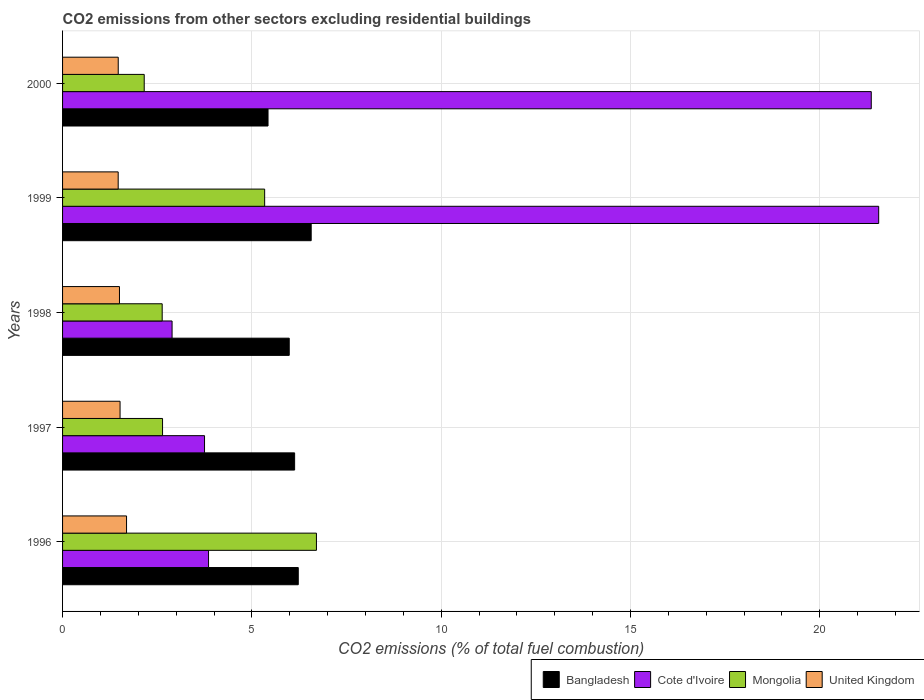How many different coloured bars are there?
Offer a very short reply. 4. Are the number of bars on each tick of the Y-axis equal?
Give a very brief answer. Yes. In how many cases, is the number of bars for a given year not equal to the number of legend labels?
Offer a very short reply. 0. What is the total CO2 emitted in Bangladesh in 1999?
Keep it short and to the point. 6.57. Across all years, what is the maximum total CO2 emitted in Mongolia?
Ensure brevity in your answer.  6.71. Across all years, what is the minimum total CO2 emitted in Cote d'Ivoire?
Offer a very short reply. 2.89. In which year was the total CO2 emitted in Mongolia minimum?
Offer a terse response. 2000. What is the total total CO2 emitted in Cote d'Ivoire in the graph?
Your response must be concise. 53.42. What is the difference between the total CO2 emitted in Bangladesh in 1996 and that in 1997?
Give a very brief answer. 0.1. What is the difference between the total CO2 emitted in United Kingdom in 1996 and the total CO2 emitted in Cote d'Ivoire in 1999?
Your answer should be compact. -19.87. What is the average total CO2 emitted in Cote d'Ivoire per year?
Make the answer very short. 10.68. In the year 1996, what is the difference between the total CO2 emitted in Bangladesh and total CO2 emitted in Cote d'Ivoire?
Your answer should be very brief. 2.37. What is the ratio of the total CO2 emitted in Bangladesh in 1996 to that in 1997?
Make the answer very short. 1.02. Is the total CO2 emitted in Mongolia in 1999 less than that in 2000?
Provide a succinct answer. No. Is the difference between the total CO2 emitted in Bangladesh in 1996 and 1998 greater than the difference between the total CO2 emitted in Cote d'Ivoire in 1996 and 1998?
Offer a very short reply. No. What is the difference between the highest and the second highest total CO2 emitted in United Kingdom?
Ensure brevity in your answer.  0.17. What is the difference between the highest and the lowest total CO2 emitted in Mongolia?
Your response must be concise. 4.55. In how many years, is the total CO2 emitted in Bangladesh greater than the average total CO2 emitted in Bangladesh taken over all years?
Provide a succinct answer. 3. Is the sum of the total CO2 emitted in Cote d'Ivoire in 1999 and 2000 greater than the maximum total CO2 emitted in Mongolia across all years?
Offer a terse response. Yes. What does the 2nd bar from the bottom in 1997 represents?
Your response must be concise. Cote d'Ivoire. What is the difference between two consecutive major ticks on the X-axis?
Provide a succinct answer. 5. Are the values on the major ticks of X-axis written in scientific E-notation?
Your answer should be very brief. No. Where does the legend appear in the graph?
Your answer should be very brief. Bottom right. How many legend labels are there?
Offer a terse response. 4. How are the legend labels stacked?
Provide a succinct answer. Horizontal. What is the title of the graph?
Make the answer very short. CO2 emissions from other sectors excluding residential buildings. What is the label or title of the X-axis?
Give a very brief answer. CO2 emissions (% of total fuel combustion). What is the label or title of the Y-axis?
Offer a terse response. Years. What is the CO2 emissions (% of total fuel combustion) of Bangladesh in 1996?
Provide a succinct answer. 6.23. What is the CO2 emissions (% of total fuel combustion) of Cote d'Ivoire in 1996?
Make the answer very short. 3.86. What is the CO2 emissions (% of total fuel combustion) of Mongolia in 1996?
Your response must be concise. 6.71. What is the CO2 emissions (% of total fuel combustion) in United Kingdom in 1996?
Offer a terse response. 1.69. What is the CO2 emissions (% of total fuel combustion) of Bangladesh in 1997?
Offer a very short reply. 6.13. What is the CO2 emissions (% of total fuel combustion) in Cote d'Ivoire in 1997?
Your response must be concise. 3.75. What is the CO2 emissions (% of total fuel combustion) of Mongolia in 1997?
Give a very brief answer. 2.64. What is the CO2 emissions (% of total fuel combustion) in United Kingdom in 1997?
Ensure brevity in your answer.  1.52. What is the CO2 emissions (% of total fuel combustion) in Bangladesh in 1998?
Give a very brief answer. 5.99. What is the CO2 emissions (% of total fuel combustion) in Cote d'Ivoire in 1998?
Make the answer very short. 2.89. What is the CO2 emissions (% of total fuel combustion) of Mongolia in 1998?
Keep it short and to the point. 2.63. What is the CO2 emissions (% of total fuel combustion) of United Kingdom in 1998?
Provide a short and direct response. 1.5. What is the CO2 emissions (% of total fuel combustion) in Bangladesh in 1999?
Offer a terse response. 6.57. What is the CO2 emissions (% of total fuel combustion) in Cote d'Ivoire in 1999?
Give a very brief answer. 21.56. What is the CO2 emissions (% of total fuel combustion) in Mongolia in 1999?
Provide a short and direct response. 5.34. What is the CO2 emissions (% of total fuel combustion) of United Kingdom in 1999?
Make the answer very short. 1.47. What is the CO2 emissions (% of total fuel combustion) in Bangladesh in 2000?
Offer a terse response. 5.43. What is the CO2 emissions (% of total fuel combustion) of Cote d'Ivoire in 2000?
Provide a short and direct response. 21.36. What is the CO2 emissions (% of total fuel combustion) in Mongolia in 2000?
Give a very brief answer. 2.16. What is the CO2 emissions (% of total fuel combustion) of United Kingdom in 2000?
Give a very brief answer. 1.47. Across all years, what is the maximum CO2 emissions (% of total fuel combustion) of Bangladesh?
Provide a succinct answer. 6.57. Across all years, what is the maximum CO2 emissions (% of total fuel combustion) in Cote d'Ivoire?
Offer a terse response. 21.56. Across all years, what is the maximum CO2 emissions (% of total fuel combustion) of Mongolia?
Provide a succinct answer. 6.71. Across all years, what is the maximum CO2 emissions (% of total fuel combustion) of United Kingdom?
Your answer should be very brief. 1.69. Across all years, what is the minimum CO2 emissions (% of total fuel combustion) in Bangladesh?
Your answer should be very brief. 5.43. Across all years, what is the minimum CO2 emissions (% of total fuel combustion) of Cote d'Ivoire?
Keep it short and to the point. 2.89. Across all years, what is the minimum CO2 emissions (% of total fuel combustion) in Mongolia?
Provide a succinct answer. 2.16. Across all years, what is the minimum CO2 emissions (% of total fuel combustion) of United Kingdom?
Keep it short and to the point. 1.47. What is the total CO2 emissions (% of total fuel combustion) of Bangladesh in the graph?
Give a very brief answer. 30.34. What is the total CO2 emissions (% of total fuel combustion) in Cote d'Ivoire in the graph?
Your answer should be compact. 53.42. What is the total CO2 emissions (% of total fuel combustion) in Mongolia in the graph?
Give a very brief answer. 19.47. What is the total CO2 emissions (% of total fuel combustion) in United Kingdom in the graph?
Ensure brevity in your answer.  7.65. What is the difference between the CO2 emissions (% of total fuel combustion) of Bangladesh in 1996 and that in 1997?
Keep it short and to the point. 0.1. What is the difference between the CO2 emissions (% of total fuel combustion) in Cote d'Ivoire in 1996 and that in 1997?
Provide a short and direct response. 0.11. What is the difference between the CO2 emissions (% of total fuel combustion) of Mongolia in 1996 and that in 1997?
Your answer should be compact. 4.06. What is the difference between the CO2 emissions (% of total fuel combustion) in United Kingdom in 1996 and that in 1997?
Offer a very short reply. 0.17. What is the difference between the CO2 emissions (% of total fuel combustion) in Bangladesh in 1996 and that in 1998?
Keep it short and to the point. 0.24. What is the difference between the CO2 emissions (% of total fuel combustion) of Cote d'Ivoire in 1996 and that in 1998?
Keep it short and to the point. 0.96. What is the difference between the CO2 emissions (% of total fuel combustion) in Mongolia in 1996 and that in 1998?
Make the answer very short. 4.07. What is the difference between the CO2 emissions (% of total fuel combustion) in United Kingdom in 1996 and that in 1998?
Make the answer very short. 0.19. What is the difference between the CO2 emissions (% of total fuel combustion) of Bangladesh in 1996 and that in 1999?
Make the answer very short. -0.34. What is the difference between the CO2 emissions (% of total fuel combustion) in Cote d'Ivoire in 1996 and that in 1999?
Your response must be concise. -17.7. What is the difference between the CO2 emissions (% of total fuel combustion) in Mongolia in 1996 and that in 1999?
Provide a short and direct response. 1.37. What is the difference between the CO2 emissions (% of total fuel combustion) of United Kingdom in 1996 and that in 1999?
Offer a very short reply. 0.22. What is the difference between the CO2 emissions (% of total fuel combustion) in Bangladesh in 1996 and that in 2000?
Provide a short and direct response. 0.8. What is the difference between the CO2 emissions (% of total fuel combustion) of Cote d'Ivoire in 1996 and that in 2000?
Your answer should be compact. -17.5. What is the difference between the CO2 emissions (% of total fuel combustion) of Mongolia in 1996 and that in 2000?
Ensure brevity in your answer.  4.55. What is the difference between the CO2 emissions (% of total fuel combustion) in United Kingdom in 1996 and that in 2000?
Offer a terse response. 0.22. What is the difference between the CO2 emissions (% of total fuel combustion) of Bangladesh in 1997 and that in 1998?
Your answer should be compact. 0.14. What is the difference between the CO2 emissions (% of total fuel combustion) of Cote d'Ivoire in 1997 and that in 1998?
Offer a very short reply. 0.86. What is the difference between the CO2 emissions (% of total fuel combustion) of Mongolia in 1997 and that in 1998?
Your answer should be compact. 0.01. What is the difference between the CO2 emissions (% of total fuel combustion) in United Kingdom in 1997 and that in 1998?
Offer a terse response. 0.02. What is the difference between the CO2 emissions (% of total fuel combustion) in Bangladesh in 1997 and that in 1999?
Provide a succinct answer. -0.44. What is the difference between the CO2 emissions (% of total fuel combustion) in Cote d'Ivoire in 1997 and that in 1999?
Ensure brevity in your answer.  -17.81. What is the difference between the CO2 emissions (% of total fuel combustion) in Mongolia in 1997 and that in 1999?
Your answer should be very brief. -2.7. What is the difference between the CO2 emissions (% of total fuel combustion) of United Kingdom in 1997 and that in 1999?
Provide a succinct answer. 0.05. What is the difference between the CO2 emissions (% of total fuel combustion) in Bangladesh in 1997 and that in 2000?
Offer a very short reply. 0.7. What is the difference between the CO2 emissions (% of total fuel combustion) of Cote d'Ivoire in 1997 and that in 2000?
Your answer should be compact. -17.61. What is the difference between the CO2 emissions (% of total fuel combustion) in Mongolia in 1997 and that in 2000?
Provide a short and direct response. 0.48. What is the difference between the CO2 emissions (% of total fuel combustion) in United Kingdom in 1997 and that in 2000?
Your answer should be compact. 0.05. What is the difference between the CO2 emissions (% of total fuel combustion) in Bangladesh in 1998 and that in 1999?
Provide a succinct answer. -0.58. What is the difference between the CO2 emissions (% of total fuel combustion) of Cote d'Ivoire in 1998 and that in 1999?
Your answer should be very brief. -18.66. What is the difference between the CO2 emissions (% of total fuel combustion) of Mongolia in 1998 and that in 1999?
Offer a terse response. -2.71. What is the difference between the CO2 emissions (% of total fuel combustion) in United Kingdom in 1998 and that in 1999?
Keep it short and to the point. 0.03. What is the difference between the CO2 emissions (% of total fuel combustion) in Bangladesh in 1998 and that in 2000?
Offer a very short reply. 0.56. What is the difference between the CO2 emissions (% of total fuel combustion) in Cote d'Ivoire in 1998 and that in 2000?
Your answer should be compact. -18.47. What is the difference between the CO2 emissions (% of total fuel combustion) in Mongolia in 1998 and that in 2000?
Make the answer very short. 0.47. What is the difference between the CO2 emissions (% of total fuel combustion) of United Kingdom in 1998 and that in 2000?
Make the answer very short. 0.03. What is the difference between the CO2 emissions (% of total fuel combustion) in Bangladesh in 1999 and that in 2000?
Ensure brevity in your answer.  1.14. What is the difference between the CO2 emissions (% of total fuel combustion) in Cote d'Ivoire in 1999 and that in 2000?
Provide a short and direct response. 0.2. What is the difference between the CO2 emissions (% of total fuel combustion) in Mongolia in 1999 and that in 2000?
Your answer should be compact. 3.18. What is the difference between the CO2 emissions (% of total fuel combustion) of United Kingdom in 1999 and that in 2000?
Give a very brief answer. -0. What is the difference between the CO2 emissions (% of total fuel combustion) in Bangladesh in 1996 and the CO2 emissions (% of total fuel combustion) in Cote d'Ivoire in 1997?
Keep it short and to the point. 2.48. What is the difference between the CO2 emissions (% of total fuel combustion) in Bangladesh in 1996 and the CO2 emissions (% of total fuel combustion) in Mongolia in 1997?
Your response must be concise. 3.58. What is the difference between the CO2 emissions (% of total fuel combustion) of Bangladesh in 1996 and the CO2 emissions (% of total fuel combustion) of United Kingdom in 1997?
Offer a very short reply. 4.71. What is the difference between the CO2 emissions (% of total fuel combustion) of Cote d'Ivoire in 1996 and the CO2 emissions (% of total fuel combustion) of Mongolia in 1997?
Provide a short and direct response. 1.22. What is the difference between the CO2 emissions (% of total fuel combustion) in Cote d'Ivoire in 1996 and the CO2 emissions (% of total fuel combustion) in United Kingdom in 1997?
Your answer should be compact. 2.34. What is the difference between the CO2 emissions (% of total fuel combustion) of Mongolia in 1996 and the CO2 emissions (% of total fuel combustion) of United Kingdom in 1997?
Provide a succinct answer. 5.19. What is the difference between the CO2 emissions (% of total fuel combustion) in Bangladesh in 1996 and the CO2 emissions (% of total fuel combustion) in Cote d'Ivoire in 1998?
Make the answer very short. 3.33. What is the difference between the CO2 emissions (% of total fuel combustion) of Bangladesh in 1996 and the CO2 emissions (% of total fuel combustion) of Mongolia in 1998?
Your answer should be compact. 3.59. What is the difference between the CO2 emissions (% of total fuel combustion) in Bangladesh in 1996 and the CO2 emissions (% of total fuel combustion) in United Kingdom in 1998?
Your answer should be very brief. 4.72. What is the difference between the CO2 emissions (% of total fuel combustion) of Cote d'Ivoire in 1996 and the CO2 emissions (% of total fuel combustion) of Mongolia in 1998?
Offer a terse response. 1.22. What is the difference between the CO2 emissions (% of total fuel combustion) in Cote d'Ivoire in 1996 and the CO2 emissions (% of total fuel combustion) in United Kingdom in 1998?
Keep it short and to the point. 2.35. What is the difference between the CO2 emissions (% of total fuel combustion) of Mongolia in 1996 and the CO2 emissions (% of total fuel combustion) of United Kingdom in 1998?
Your answer should be very brief. 5.2. What is the difference between the CO2 emissions (% of total fuel combustion) in Bangladesh in 1996 and the CO2 emissions (% of total fuel combustion) in Cote d'Ivoire in 1999?
Offer a terse response. -15.33. What is the difference between the CO2 emissions (% of total fuel combustion) in Bangladesh in 1996 and the CO2 emissions (% of total fuel combustion) in Mongolia in 1999?
Give a very brief answer. 0.89. What is the difference between the CO2 emissions (% of total fuel combustion) of Bangladesh in 1996 and the CO2 emissions (% of total fuel combustion) of United Kingdom in 1999?
Make the answer very short. 4.76. What is the difference between the CO2 emissions (% of total fuel combustion) of Cote d'Ivoire in 1996 and the CO2 emissions (% of total fuel combustion) of Mongolia in 1999?
Your answer should be very brief. -1.48. What is the difference between the CO2 emissions (% of total fuel combustion) in Cote d'Ivoire in 1996 and the CO2 emissions (% of total fuel combustion) in United Kingdom in 1999?
Keep it short and to the point. 2.39. What is the difference between the CO2 emissions (% of total fuel combustion) of Mongolia in 1996 and the CO2 emissions (% of total fuel combustion) of United Kingdom in 1999?
Your answer should be compact. 5.24. What is the difference between the CO2 emissions (% of total fuel combustion) in Bangladesh in 1996 and the CO2 emissions (% of total fuel combustion) in Cote d'Ivoire in 2000?
Give a very brief answer. -15.14. What is the difference between the CO2 emissions (% of total fuel combustion) of Bangladesh in 1996 and the CO2 emissions (% of total fuel combustion) of Mongolia in 2000?
Give a very brief answer. 4.07. What is the difference between the CO2 emissions (% of total fuel combustion) of Bangladesh in 1996 and the CO2 emissions (% of total fuel combustion) of United Kingdom in 2000?
Offer a terse response. 4.76. What is the difference between the CO2 emissions (% of total fuel combustion) in Cote d'Ivoire in 1996 and the CO2 emissions (% of total fuel combustion) in Mongolia in 2000?
Make the answer very short. 1.7. What is the difference between the CO2 emissions (% of total fuel combustion) in Cote d'Ivoire in 1996 and the CO2 emissions (% of total fuel combustion) in United Kingdom in 2000?
Offer a very short reply. 2.39. What is the difference between the CO2 emissions (% of total fuel combustion) in Mongolia in 1996 and the CO2 emissions (% of total fuel combustion) in United Kingdom in 2000?
Keep it short and to the point. 5.24. What is the difference between the CO2 emissions (% of total fuel combustion) in Bangladesh in 1997 and the CO2 emissions (% of total fuel combustion) in Cote d'Ivoire in 1998?
Provide a succinct answer. 3.24. What is the difference between the CO2 emissions (% of total fuel combustion) of Bangladesh in 1997 and the CO2 emissions (% of total fuel combustion) of Mongolia in 1998?
Ensure brevity in your answer.  3.5. What is the difference between the CO2 emissions (% of total fuel combustion) in Bangladesh in 1997 and the CO2 emissions (% of total fuel combustion) in United Kingdom in 1998?
Provide a succinct answer. 4.63. What is the difference between the CO2 emissions (% of total fuel combustion) of Cote d'Ivoire in 1997 and the CO2 emissions (% of total fuel combustion) of Mongolia in 1998?
Provide a succinct answer. 1.12. What is the difference between the CO2 emissions (% of total fuel combustion) in Cote d'Ivoire in 1997 and the CO2 emissions (% of total fuel combustion) in United Kingdom in 1998?
Your answer should be very brief. 2.25. What is the difference between the CO2 emissions (% of total fuel combustion) in Mongolia in 1997 and the CO2 emissions (% of total fuel combustion) in United Kingdom in 1998?
Your response must be concise. 1.14. What is the difference between the CO2 emissions (% of total fuel combustion) of Bangladesh in 1997 and the CO2 emissions (% of total fuel combustion) of Cote d'Ivoire in 1999?
Make the answer very short. -15.43. What is the difference between the CO2 emissions (% of total fuel combustion) of Bangladesh in 1997 and the CO2 emissions (% of total fuel combustion) of Mongolia in 1999?
Make the answer very short. 0.79. What is the difference between the CO2 emissions (% of total fuel combustion) of Bangladesh in 1997 and the CO2 emissions (% of total fuel combustion) of United Kingdom in 1999?
Offer a terse response. 4.66. What is the difference between the CO2 emissions (% of total fuel combustion) in Cote d'Ivoire in 1997 and the CO2 emissions (% of total fuel combustion) in Mongolia in 1999?
Your answer should be very brief. -1.59. What is the difference between the CO2 emissions (% of total fuel combustion) of Cote d'Ivoire in 1997 and the CO2 emissions (% of total fuel combustion) of United Kingdom in 1999?
Provide a short and direct response. 2.28. What is the difference between the CO2 emissions (% of total fuel combustion) in Mongolia in 1997 and the CO2 emissions (% of total fuel combustion) in United Kingdom in 1999?
Offer a terse response. 1.17. What is the difference between the CO2 emissions (% of total fuel combustion) of Bangladesh in 1997 and the CO2 emissions (% of total fuel combustion) of Cote d'Ivoire in 2000?
Provide a short and direct response. -15.23. What is the difference between the CO2 emissions (% of total fuel combustion) in Bangladesh in 1997 and the CO2 emissions (% of total fuel combustion) in Mongolia in 2000?
Give a very brief answer. 3.97. What is the difference between the CO2 emissions (% of total fuel combustion) of Bangladesh in 1997 and the CO2 emissions (% of total fuel combustion) of United Kingdom in 2000?
Give a very brief answer. 4.66. What is the difference between the CO2 emissions (% of total fuel combustion) in Cote d'Ivoire in 1997 and the CO2 emissions (% of total fuel combustion) in Mongolia in 2000?
Ensure brevity in your answer.  1.59. What is the difference between the CO2 emissions (% of total fuel combustion) of Cote d'Ivoire in 1997 and the CO2 emissions (% of total fuel combustion) of United Kingdom in 2000?
Keep it short and to the point. 2.28. What is the difference between the CO2 emissions (% of total fuel combustion) in Mongolia in 1997 and the CO2 emissions (% of total fuel combustion) in United Kingdom in 2000?
Keep it short and to the point. 1.17. What is the difference between the CO2 emissions (% of total fuel combustion) of Bangladesh in 1998 and the CO2 emissions (% of total fuel combustion) of Cote d'Ivoire in 1999?
Provide a short and direct response. -15.57. What is the difference between the CO2 emissions (% of total fuel combustion) in Bangladesh in 1998 and the CO2 emissions (% of total fuel combustion) in Mongolia in 1999?
Give a very brief answer. 0.65. What is the difference between the CO2 emissions (% of total fuel combustion) in Bangladesh in 1998 and the CO2 emissions (% of total fuel combustion) in United Kingdom in 1999?
Make the answer very short. 4.52. What is the difference between the CO2 emissions (% of total fuel combustion) of Cote d'Ivoire in 1998 and the CO2 emissions (% of total fuel combustion) of Mongolia in 1999?
Your answer should be compact. -2.45. What is the difference between the CO2 emissions (% of total fuel combustion) of Cote d'Ivoire in 1998 and the CO2 emissions (% of total fuel combustion) of United Kingdom in 1999?
Offer a very short reply. 1.42. What is the difference between the CO2 emissions (% of total fuel combustion) of Mongolia in 1998 and the CO2 emissions (% of total fuel combustion) of United Kingdom in 1999?
Your response must be concise. 1.16. What is the difference between the CO2 emissions (% of total fuel combustion) of Bangladesh in 1998 and the CO2 emissions (% of total fuel combustion) of Cote d'Ivoire in 2000?
Offer a terse response. -15.37. What is the difference between the CO2 emissions (% of total fuel combustion) of Bangladesh in 1998 and the CO2 emissions (% of total fuel combustion) of Mongolia in 2000?
Provide a succinct answer. 3.83. What is the difference between the CO2 emissions (% of total fuel combustion) of Bangladesh in 1998 and the CO2 emissions (% of total fuel combustion) of United Kingdom in 2000?
Make the answer very short. 4.52. What is the difference between the CO2 emissions (% of total fuel combustion) in Cote d'Ivoire in 1998 and the CO2 emissions (% of total fuel combustion) in Mongolia in 2000?
Give a very brief answer. 0.74. What is the difference between the CO2 emissions (% of total fuel combustion) in Cote d'Ivoire in 1998 and the CO2 emissions (% of total fuel combustion) in United Kingdom in 2000?
Offer a very short reply. 1.42. What is the difference between the CO2 emissions (% of total fuel combustion) of Mongolia in 1998 and the CO2 emissions (% of total fuel combustion) of United Kingdom in 2000?
Ensure brevity in your answer.  1.16. What is the difference between the CO2 emissions (% of total fuel combustion) of Bangladesh in 1999 and the CO2 emissions (% of total fuel combustion) of Cote d'Ivoire in 2000?
Give a very brief answer. -14.79. What is the difference between the CO2 emissions (% of total fuel combustion) in Bangladesh in 1999 and the CO2 emissions (% of total fuel combustion) in Mongolia in 2000?
Give a very brief answer. 4.41. What is the difference between the CO2 emissions (% of total fuel combustion) of Bangladesh in 1999 and the CO2 emissions (% of total fuel combustion) of United Kingdom in 2000?
Provide a succinct answer. 5.1. What is the difference between the CO2 emissions (% of total fuel combustion) in Cote d'Ivoire in 1999 and the CO2 emissions (% of total fuel combustion) in Mongolia in 2000?
Your answer should be very brief. 19.4. What is the difference between the CO2 emissions (% of total fuel combustion) of Cote d'Ivoire in 1999 and the CO2 emissions (% of total fuel combustion) of United Kingdom in 2000?
Your answer should be very brief. 20.09. What is the difference between the CO2 emissions (% of total fuel combustion) of Mongolia in 1999 and the CO2 emissions (% of total fuel combustion) of United Kingdom in 2000?
Provide a succinct answer. 3.87. What is the average CO2 emissions (% of total fuel combustion) of Bangladesh per year?
Provide a succinct answer. 6.07. What is the average CO2 emissions (% of total fuel combustion) in Cote d'Ivoire per year?
Offer a terse response. 10.68. What is the average CO2 emissions (% of total fuel combustion) of Mongolia per year?
Make the answer very short. 3.89. What is the average CO2 emissions (% of total fuel combustion) of United Kingdom per year?
Your answer should be very brief. 1.53. In the year 1996, what is the difference between the CO2 emissions (% of total fuel combustion) in Bangladesh and CO2 emissions (% of total fuel combustion) in Cote d'Ivoire?
Offer a terse response. 2.37. In the year 1996, what is the difference between the CO2 emissions (% of total fuel combustion) of Bangladesh and CO2 emissions (% of total fuel combustion) of Mongolia?
Offer a very short reply. -0.48. In the year 1996, what is the difference between the CO2 emissions (% of total fuel combustion) of Bangladesh and CO2 emissions (% of total fuel combustion) of United Kingdom?
Ensure brevity in your answer.  4.54. In the year 1996, what is the difference between the CO2 emissions (% of total fuel combustion) of Cote d'Ivoire and CO2 emissions (% of total fuel combustion) of Mongolia?
Keep it short and to the point. -2.85. In the year 1996, what is the difference between the CO2 emissions (% of total fuel combustion) of Cote d'Ivoire and CO2 emissions (% of total fuel combustion) of United Kingdom?
Ensure brevity in your answer.  2.17. In the year 1996, what is the difference between the CO2 emissions (% of total fuel combustion) in Mongolia and CO2 emissions (% of total fuel combustion) in United Kingdom?
Your response must be concise. 5.02. In the year 1997, what is the difference between the CO2 emissions (% of total fuel combustion) in Bangladesh and CO2 emissions (% of total fuel combustion) in Cote d'Ivoire?
Offer a terse response. 2.38. In the year 1997, what is the difference between the CO2 emissions (% of total fuel combustion) in Bangladesh and CO2 emissions (% of total fuel combustion) in Mongolia?
Your answer should be very brief. 3.49. In the year 1997, what is the difference between the CO2 emissions (% of total fuel combustion) of Bangladesh and CO2 emissions (% of total fuel combustion) of United Kingdom?
Provide a succinct answer. 4.61. In the year 1997, what is the difference between the CO2 emissions (% of total fuel combustion) of Cote d'Ivoire and CO2 emissions (% of total fuel combustion) of Mongolia?
Offer a terse response. 1.11. In the year 1997, what is the difference between the CO2 emissions (% of total fuel combustion) of Cote d'Ivoire and CO2 emissions (% of total fuel combustion) of United Kingdom?
Offer a terse response. 2.23. In the year 1997, what is the difference between the CO2 emissions (% of total fuel combustion) in Mongolia and CO2 emissions (% of total fuel combustion) in United Kingdom?
Provide a succinct answer. 1.12. In the year 1998, what is the difference between the CO2 emissions (% of total fuel combustion) in Bangladesh and CO2 emissions (% of total fuel combustion) in Cote d'Ivoire?
Your answer should be very brief. 3.09. In the year 1998, what is the difference between the CO2 emissions (% of total fuel combustion) of Bangladesh and CO2 emissions (% of total fuel combustion) of Mongolia?
Provide a succinct answer. 3.36. In the year 1998, what is the difference between the CO2 emissions (% of total fuel combustion) in Bangladesh and CO2 emissions (% of total fuel combustion) in United Kingdom?
Make the answer very short. 4.48. In the year 1998, what is the difference between the CO2 emissions (% of total fuel combustion) in Cote d'Ivoire and CO2 emissions (% of total fuel combustion) in Mongolia?
Offer a terse response. 0.26. In the year 1998, what is the difference between the CO2 emissions (% of total fuel combustion) in Cote d'Ivoire and CO2 emissions (% of total fuel combustion) in United Kingdom?
Offer a very short reply. 1.39. In the year 1998, what is the difference between the CO2 emissions (% of total fuel combustion) of Mongolia and CO2 emissions (% of total fuel combustion) of United Kingdom?
Provide a short and direct response. 1.13. In the year 1999, what is the difference between the CO2 emissions (% of total fuel combustion) of Bangladesh and CO2 emissions (% of total fuel combustion) of Cote d'Ivoire?
Your response must be concise. -14.99. In the year 1999, what is the difference between the CO2 emissions (% of total fuel combustion) in Bangladesh and CO2 emissions (% of total fuel combustion) in Mongolia?
Provide a succinct answer. 1.23. In the year 1999, what is the difference between the CO2 emissions (% of total fuel combustion) in Bangladesh and CO2 emissions (% of total fuel combustion) in United Kingdom?
Provide a short and direct response. 5.1. In the year 1999, what is the difference between the CO2 emissions (% of total fuel combustion) in Cote d'Ivoire and CO2 emissions (% of total fuel combustion) in Mongolia?
Offer a terse response. 16.22. In the year 1999, what is the difference between the CO2 emissions (% of total fuel combustion) in Cote d'Ivoire and CO2 emissions (% of total fuel combustion) in United Kingdom?
Your response must be concise. 20.09. In the year 1999, what is the difference between the CO2 emissions (% of total fuel combustion) in Mongolia and CO2 emissions (% of total fuel combustion) in United Kingdom?
Your answer should be very brief. 3.87. In the year 2000, what is the difference between the CO2 emissions (% of total fuel combustion) of Bangladesh and CO2 emissions (% of total fuel combustion) of Cote d'Ivoire?
Your response must be concise. -15.93. In the year 2000, what is the difference between the CO2 emissions (% of total fuel combustion) of Bangladesh and CO2 emissions (% of total fuel combustion) of Mongolia?
Ensure brevity in your answer.  3.27. In the year 2000, what is the difference between the CO2 emissions (% of total fuel combustion) in Bangladesh and CO2 emissions (% of total fuel combustion) in United Kingdom?
Provide a succinct answer. 3.96. In the year 2000, what is the difference between the CO2 emissions (% of total fuel combustion) of Cote d'Ivoire and CO2 emissions (% of total fuel combustion) of Mongolia?
Provide a short and direct response. 19.2. In the year 2000, what is the difference between the CO2 emissions (% of total fuel combustion) in Cote d'Ivoire and CO2 emissions (% of total fuel combustion) in United Kingdom?
Ensure brevity in your answer.  19.89. In the year 2000, what is the difference between the CO2 emissions (% of total fuel combustion) of Mongolia and CO2 emissions (% of total fuel combustion) of United Kingdom?
Ensure brevity in your answer.  0.69. What is the ratio of the CO2 emissions (% of total fuel combustion) in Bangladesh in 1996 to that in 1997?
Ensure brevity in your answer.  1.02. What is the ratio of the CO2 emissions (% of total fuel combustion) of Cote d'Ivoire in 1996 to that in 1997?
Ensure brevity in your answer.  1.03. What is the ratio of the CO2 emissions (% of total fuel combustion) of Mongolia in 1996 to that in 1997?
Keep it short and to the point. 2.54. What is the ratio of the CO2 emissions (% of total fuel combustion) in United Kingdom in 1996 to that in 1997?
Ensure brevity in your answer.  1.11. What is the ratio of the CO2 emissions (% of total fuel combustion) of Bangladesh in 1996 to that in 1998?
Offer a very short reply. 1.04. What is the ratio of the CO2 emissions (% of total fuel combustion) of Cote d'Ivoire in 1996 to that in 1998?
Provide a short and direct response. 1.33. What is the ratio of the CO2 emissions (% of total fuel combustion) in Mongolia in 1996 to that in 1998?
Your response must be concise. 2.55. What is the ratio of the CO2 emissions (% of total fuel combustion) of United Kingdom in 1996 to that in 1998?
Keep it short and to the point. 1.12. What is the ratio of the CO2 emissions (% of total fuel combustion) of Bangladesh in 1996 to that in 1999?
Offer a very short reply. 0.95. What is the ratio of the CO2 emissions (% of total fuel combustion) in Cote d'Ivoire in 1996 to that in 1999?
Offer a terse response. 0.18. What is the ratio of the CO2 emissions (% of total fuel combustion) of Mongolia in 1996 to that in 1999?
Provide a short and direct response. 1.26. What is the ratio of the CO2 emissions (% of total fuel combustion) of United Kingdom in 1996 to that in 1999?
Provide a short and direct response. 1.15. What is the ratio of the CO2 emissions (% of total fuel combustion) of Bangladesh in 1996 to that in 2000?
Keep it short and to the point. 1.15. What is the ratio of the CO2 emissions (% of total fuel combustion) in Cote d'Ivoire in 1996 to that in 2000?
Give a very brief answer. 0.18. What is the ratio of the CO2 emissions (% of total fuel combustion) of Mongolia in 1996 to that in 2000?
Ensure brevity in your answer.  3.11. What is the ratio of the CO2 emissions (% of total fuel combustion) in United Kingdom in 1996 to that in 2000?
Your response must be concise. 1.15. What is the ratio of the CO2 emissions (% of total fuel combustion) in Bangladesh in 1997 to that in 1998?
Ensure brevity in your answer.  1.02. What is the ratio of the CO2 emissions (% of total fuel combustion) in Cote d'Ivoire in 1997 to that in 1998?
Your answer should be compact. 1.3. What is the ratio of the CO2 emissions (% of total fuel combustion) of Mongolia in 1997 to that in 1998?
Your response must be concise. 1. What is the ratio of the CO2 emissions (% of total fuel combustion) of United Kingdom in 1997 to that in 1998?
Provide a short and direct response. 1.01. What is the ratio of the CO2 emissions (% of total fuel combustion) of Bangladesh in 1997 to that in 1999?
Make the answer very short. 0.93. What is the ratio of the CO2 emissions (% of total fuel combustion) of Cote d'Ivoire in 1997 to that in 1999?
Your answer should be compact. 0.17. What is the ratio of the CO2 emissions (% of total fuel combustion) of Mongolia in 1997 to that in 1999?
Provide a short and direct response. 0.49. What is the ratio of the CO2 emissions (% of total fuel combustion) of United Kingdom in 1997 to that in 1999?
Provide a short and direct response. 1.03. What is the ratio of the CO2 emissions (% of total fuel combustion) of Bangladesh in 1997 to that in 2000?
Keep it short and to the point. 1.13. What is the ratio of the CO2 emissions (% of total fuel combustion) in Cote d'Ivoire in 1997 to that in 2000?
Your response must be concise. 0.18. What is the ratio of the CO2 emissions (% of total fuel combustion) of Mongolia in 1997 to that in 2000?
Ensure brevity in your answer.  1.22. What is the ratio of the CO2 emissions (% of total fuel combustion) in United Kingdom in 1997 to that in 2000?
Your response must be concise. 1.03. What is the ratio of the CO2 emissions (% of total fuel combustion) in Bangladesh in 1998 to that in 1999?
Your response must be concise. 0.91. What is the ratio of the CO2 emissions (% of total fuel combustion) in Cote d'Ivoire in 1998 to that in 1999?
Provide a short and direct response. 0.13. What is the ratio of the CO2 emissions (% of total fuel combustion) in Mongolia in 1998 to that in 1999?
Your answer should be compact. 0.49. What is the ratio of the CO2 emissions (% of total fuel combustion) of Bangladesh in 1998 to that in 2000?
Provide a succinct answer. 1.1. What is the ratio of the CO2 emissions (% of total fuel combustion) of Cote d'Ivoire in 1998 to that in 2000?
Provide a short and direct response. 0.14. What is the ratio of the CO2 emissions (% of total fuel combustion) of Mongolia in 1998 to that in 2000?
Give a very brief answer. 1.22. What is the ratio of the CO2 emissions (% of total fuel combustion) of Bangladesh in 1999 to that in 2000?
Provide a succinct answer. 1.21. What is the ratio of the CO2 emissions (% of total fuel combustion) in Cote d'Ivoire in 1999 to that in 2000?
Provide a short and direct response. 1.01. What is the ratio of the CO2 emissions (% of total fuel combustion) in Mongolia in 1999 to that in 2000?
Provide a succinct answer. 2.48. What is the difference between the highest and the second highest CO2 emissions (% of total fuel combustion) of Bangladesh?
Ensure brevity in your answer.  0.34. What is the difference between the highest and the second highest CO2 emissions (% of total fuel combustion) in Cote d'Ivoire?
Offer a terse response. 0.2. What is the difference between the highest and the second highest CO2 emissions (% of total fuel combustion) in Mongolia?
Give a very brief answer. 1.37. What is the difference between the highest and the second highest CO2 emissions (% of total fuel combustion) of United Kingdom?
Offer a terse response. 0.17. What is the difference between the highest and the lowest CO2 emissions (% of total fuel combustion) in Bangladesh?
Offer a very short reply. 1.14. What is the difference between the highest and the lowest CO2 emissions (% of total fuel combustion) in Cote d'Ivoire?
Offer a very short reply. 18.66. What is the difference between the highest and the lowest CO2 emissions (% of total fuel combustion) of Mongolia?
Give a very brief answer. 4.55. What is the difference between the highest and the lowest CO2 emissions (% of total fuel combustion) in United Kingdom?
Your response must be concise. 0.22. 